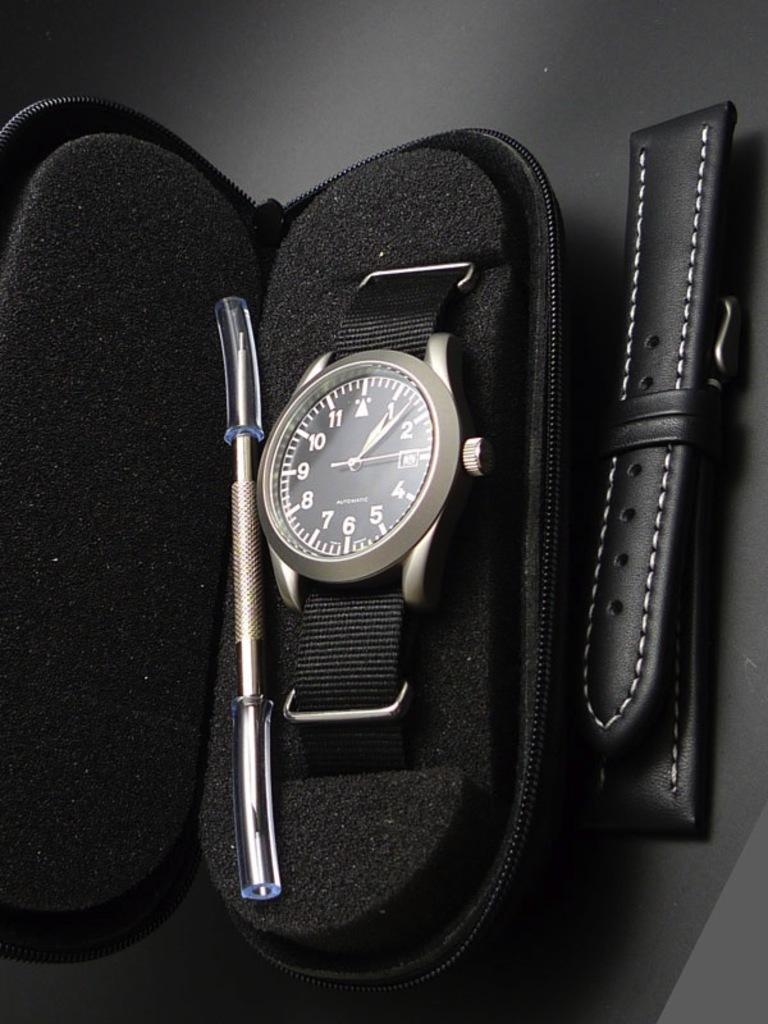<image>
Summarize the visual content of the image. A watch in a case which has the time set to nearly ten past one. 